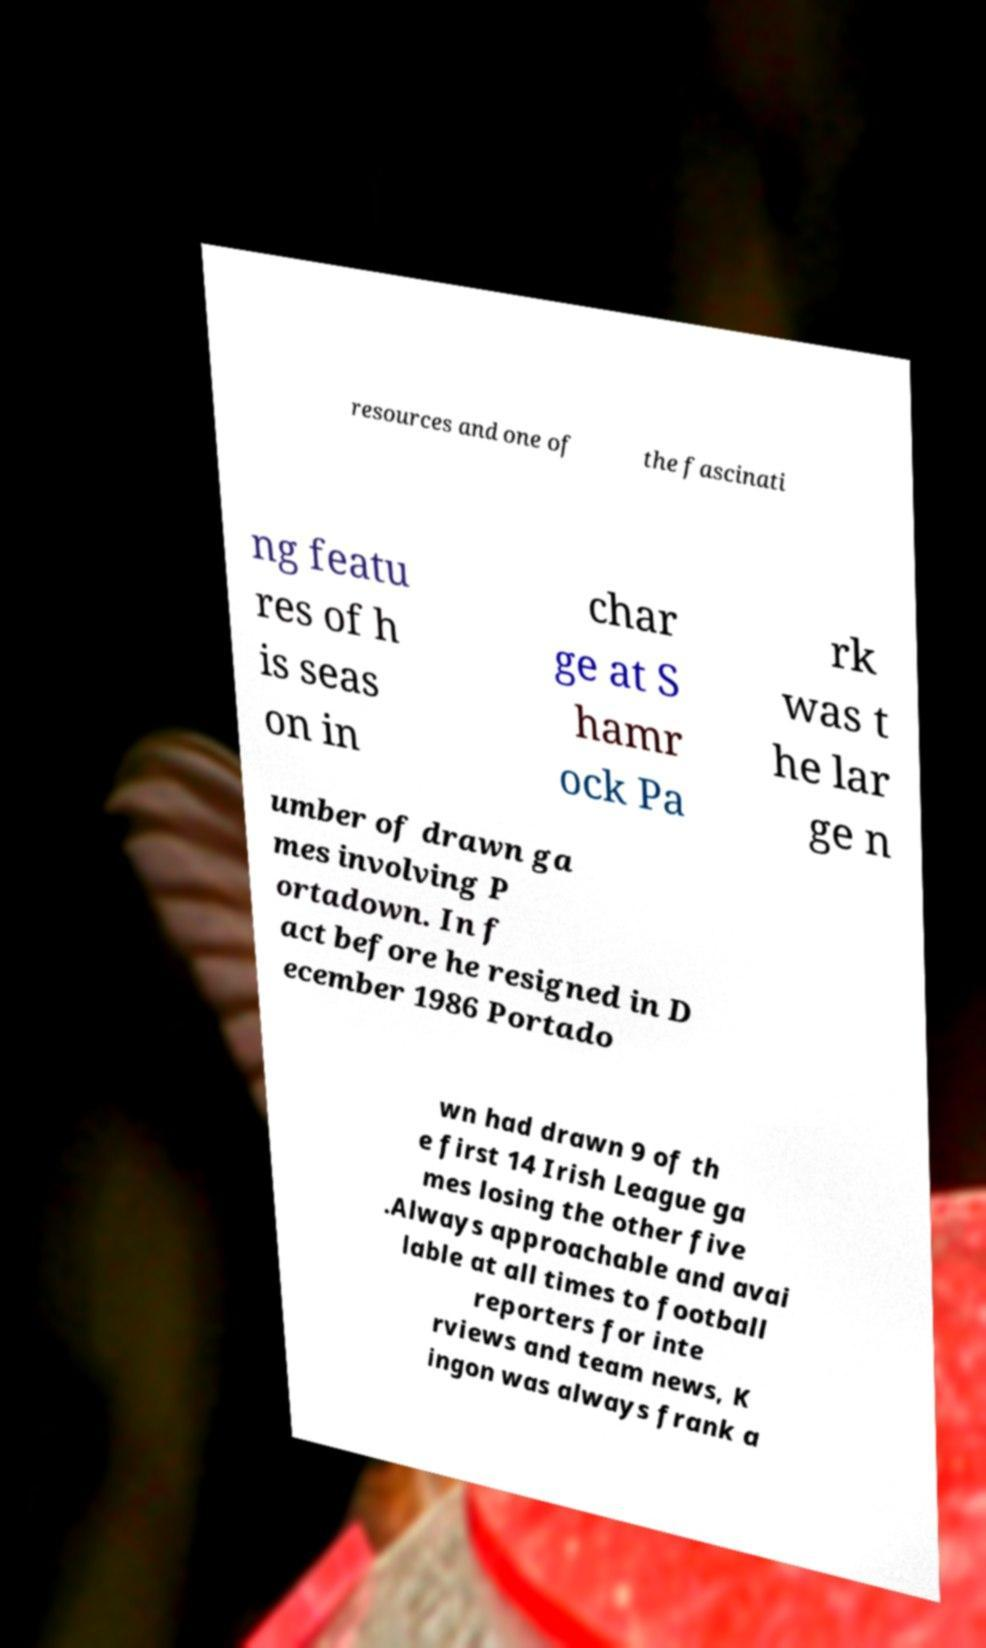What messages or text are displayed in this image? I need them in a readable, typed format. resources and one of the fascinati ng featu res of h is seas on in char ge at S hamr ock Pa rk was t he lar ge n umber of drawn ga mes involving P ortadown. In f act before he resigned in D ecember 1986 Portado wn had drawn 9 of th e first 14 Irish League ga mes losing the other five .Always approachable and avai lable at all times to football reporters for inte rviews and team news, K ingon was always frank a 